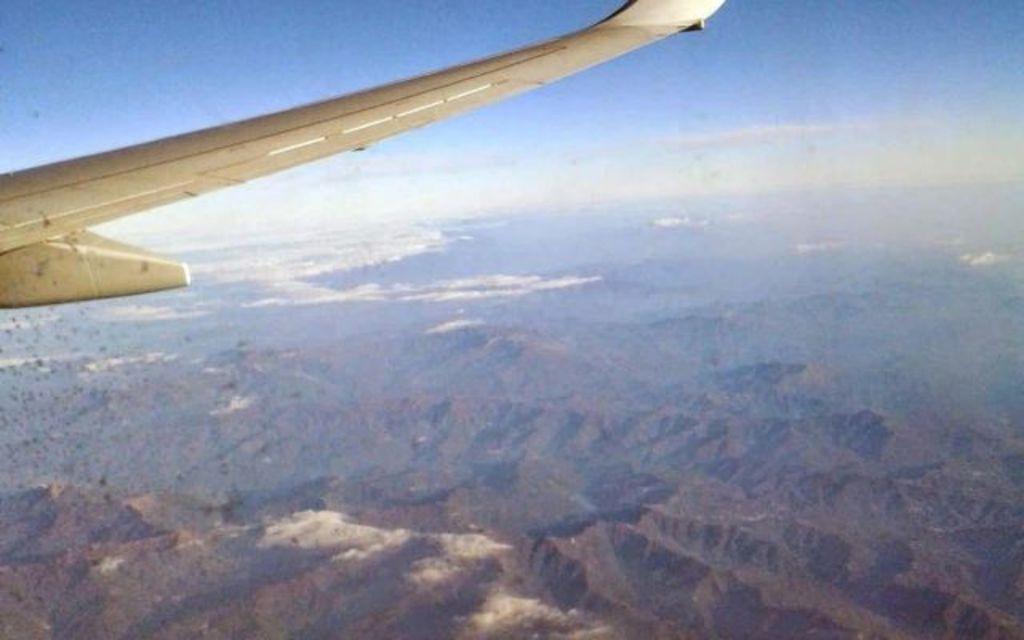How would you summarize this image in a sentence or two? In this image I can see an aircraft, trees, mountains and the sky. This image is taken may be in the evening. 